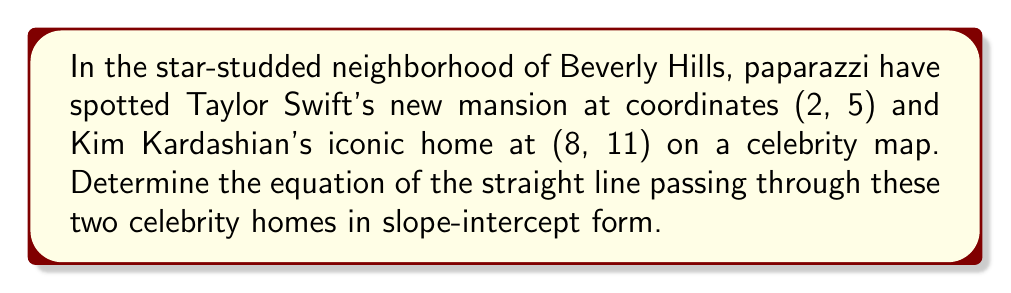Solve this math problem. Let's approach this step-by-step:

1) To find the equation of a line in slope-intercept form $(y = mx + b)$, we need to calculate the slope $(m)$ and y-intercept $(b)$.

2) First, let's calculate the slope using the slope formula:

   $m = \frac{y_2 - y_1}{x_2 - x_1}$

   Where $(x_1, y_1)$ is Taylor's home (2, 5) and $(x_2, y_2)$ is Kim's home (8, 11).

3) Plugging in the values:

   $m = \frac{11 - 5}{8 - 2} = \frac{6}{6} = 1$

4) Now that we have the slope, we can use the point-slope form of a line to find the y-intercept:

   $y - y_1 = m(x - x_1)$

5) Let's use Taylor's home coordinates (2, 5). Substituting the values:

   $y - 5 = 1(x - 2)$

6) Simplify:

   $y - 5 = x - 2$

7) Rearrange to slope-intercept form $(y = mx + b)$:

   $y = x - 2 + 5$
   $y = x + 3$

Therefore, the equation of the line passing through these celebrity homes is $y = x + 3$.
Answer: $y = x + 3$ 